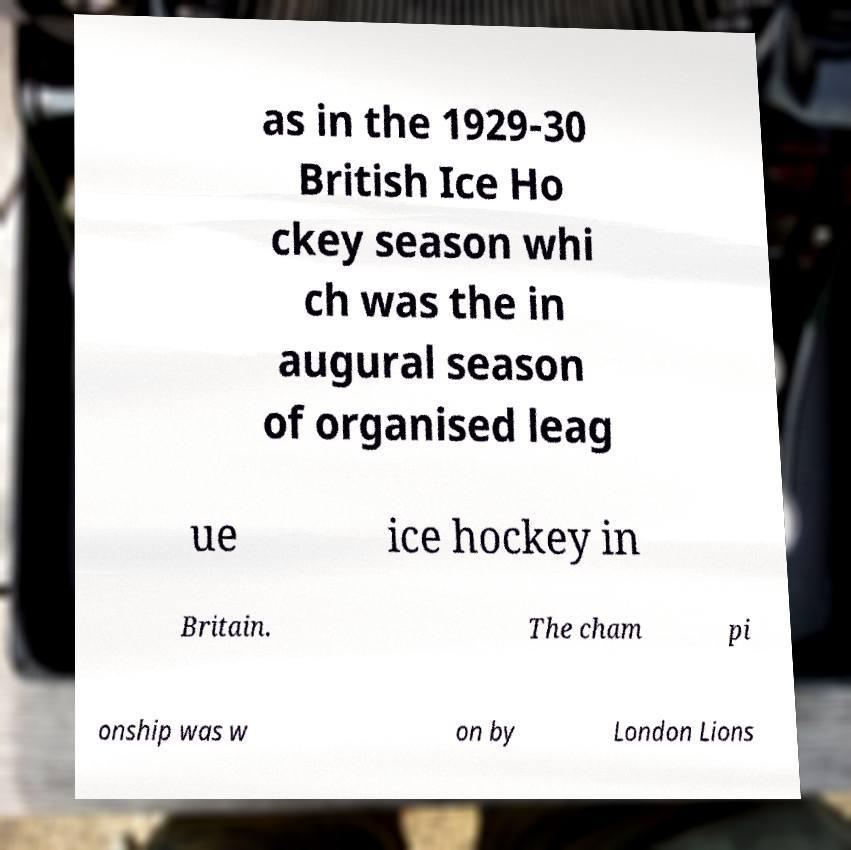Please identify and transcribe the text found in this image. as in the 1929-30 British Ice Ho ckey season whi ch was the in augural season of organised leag ue ice hockey in Britain. The cham pi onship was w on by London Lions 